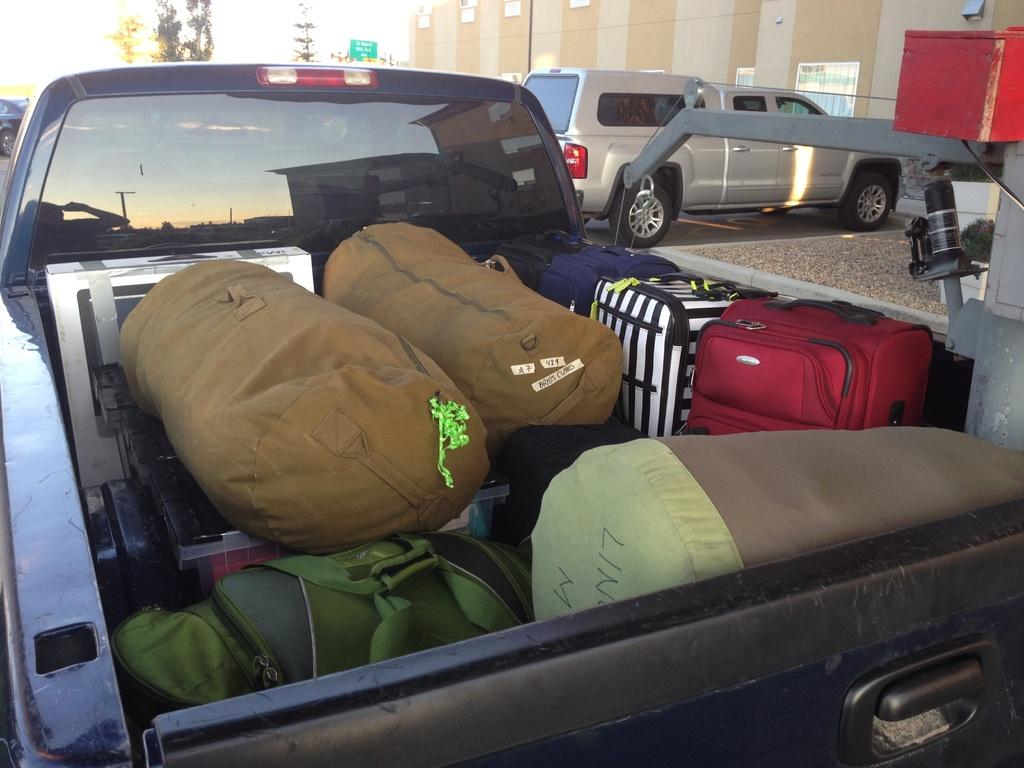What is on the road in the image? There is a vehicle on the road in the image. Can you describe any items related to travel or packing? Yes, there is luggage visible in the image. What type of natural element can be seen in the image? There is a tree in the image. What is visible in the background of the image? The sky is visible in the image. What type of tent can be seen in the image? There is no tent present in the image. What is the value of the company associated with the vehicle in the image? There is no information about a company associated with the vehicle in the image, so it is not possible to determine its value. 